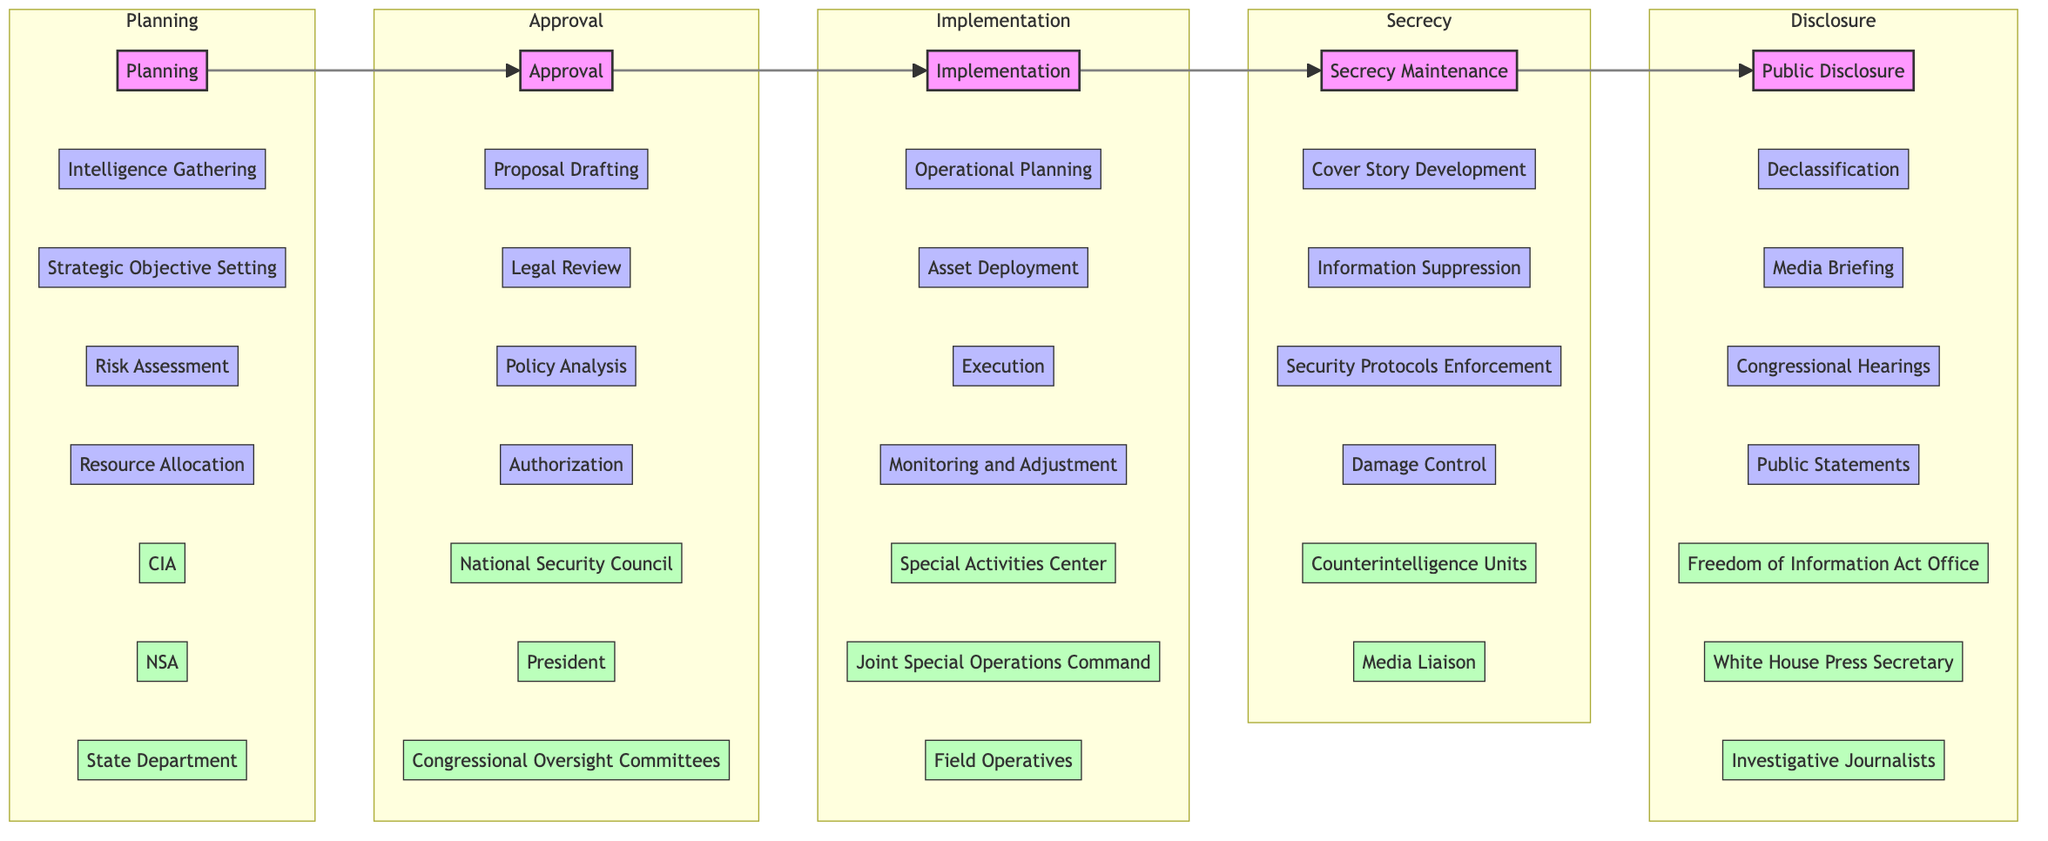What is the first stage in the lifecycle of a covert action? The diagram indicates that the first stage is "Planning," as it is the initial part of the horizontal flowchart representing the sequence of stages.
Answer: Planning How many entities are involved in the Approval stage? In the Approval stage, there are three entities listed: National Security Council, President, and Congressional Oversight Committees, making the total count three.
Answer: 3 Name one action taken during the Implementation stage. The Implementation stage includes several actions, one of which is "Execution." It is mentioned clearly in the actions listed under that stage.
Answer: Execution What is the last stage before Public Disclosure? The last stage before Public Disclosure in the flowchart is "Secrecy Maintenance." The diagram explicitly shows this as the preceding stage before reaching the final stage.
Answer: Secrecy Maintenance Which entity handles Declassification? The entity responsible for Declassification is the "Freedom of Information Act Office," which is mentioned under the Public Disclosure stage in the diagram.
Answer: Freedom of Information Act Office How many actions are there in the Planning stage? The Planning stage comprises four actions: Intelligence Gathering, Strategic Objective Setting, Risk Assessment, and Resource Allocation, totaling four actions as represented in the diagram.
Answer: 4 What action follows "Proposal Drafting" in the Approval stage? After "Proposal Drafting," the next action in the Approval stage is "Legal Review," demonstrating the sequence of actions in this phase of the lifecycle.
Answer: Legal Review Which stage includes Asset Deployment? The stage that includes "Asset Deployment" is "Implementation." The diagram indicates that this action is specifically categorized within this stage.
Answer: Implementation List one entity mentioned in the Secrecy Maintenance stage. One entity mentioned in the Secrecy Maintenance stage is "Counterintelligence Units." This entity is part of the elements indicated in the relevant stage of the flowchart.
Answer: Counterintelligence Units 